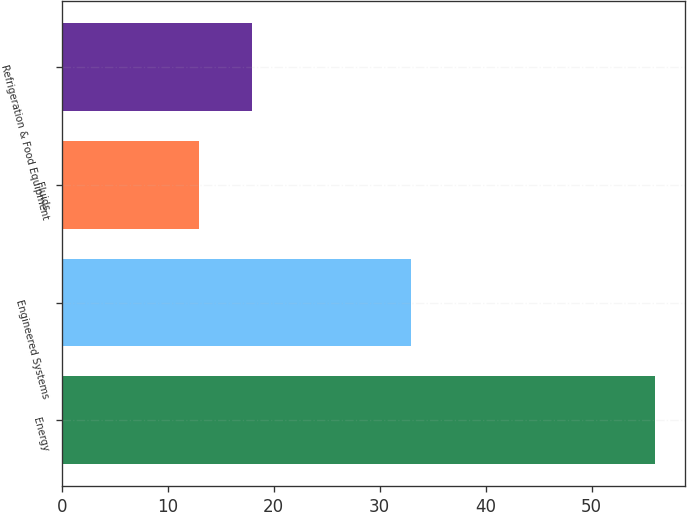Convert chart. <chart><loc_0><loc_0><loc_500><loc_500><bar_chart><fcel>Energy<fcel>Engineered Systems<fcel>Fluids<fcel>Refrigeration & Food Equipment<nl><fcel>56<fcel>33<fcel>13<fcel>18<nl></chart> 